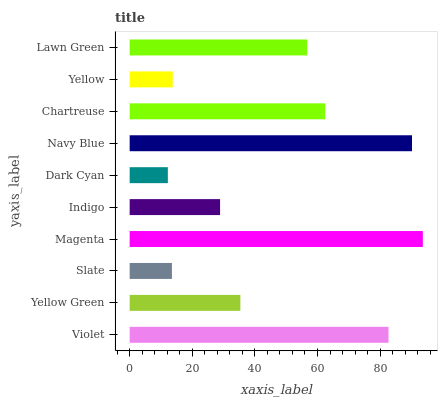Is Dark Cyan the minimum?
Answer yes or no. Yes. Is Magenta the maximum?
Answer yes or no. Yes. Is Yellow Green the minimum?
Answer yes or no. No. Is Yellow Green the maximum?
Answer yes or no. No. Is Violet greater than Yellow Green?
Answer yes or no. Yes. Is Yellow Green less than Violet?
Answer yes or no. Yes. Is Yellow Green greater than Violet?
Answer yes or no. No. Is Violet less than Yellow Green?
Answer yes or no. No. Is Lawn Green the high median?
Answer yes or no. Yes. Is Yellow Green the low median?
Answer yes or no. Yes. Is Magenta the high median?
Answer yes or no. No. Is Navy Blue the low median?
Answer yes or no. No. 